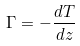Convert formula to latex. <formula><loc_0><loc_0><loc_500><loc_500>\Gamma = - { \frac { d T } { d z } }</formula> 